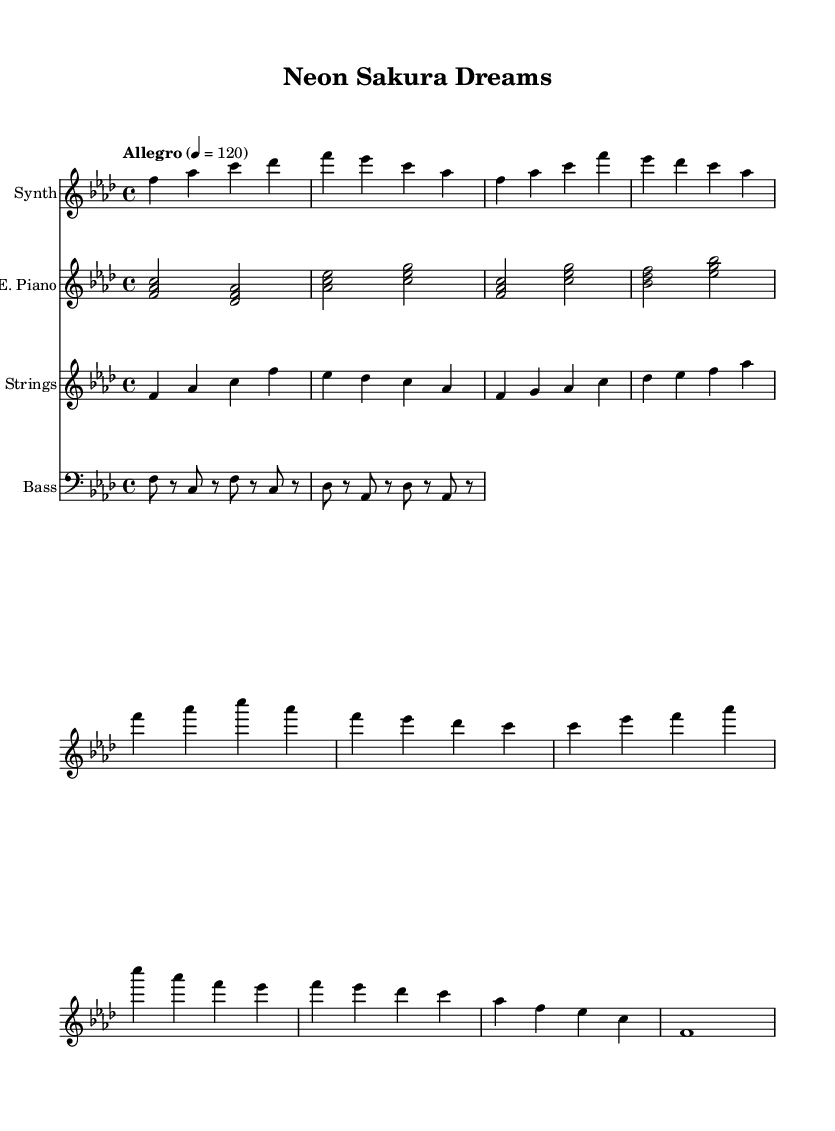What is the title of this piece? The title is indicated at the top of the sheet music in the header section. The title "Neon Sakura Dreams" is clearly labeled there.
Answer: Neon Sakura Dreams What is the key signature of this music? The key signature is found at the beginning of the staff, which indicates the sharps or flats used. Here, it shows four flats, indicating F minor.
Answer: F minor What is the time signature of this music? The time signature appears at the beginning of the score. It is written as 4/4, meaning there are four beats in each measure and the quarter note gets one beat.
Answer: 4/4 What is the tempo of this composition? The tempo marking is present at the beginning, which specifies the speed of the piece. It is indicated as "Allegro" with a metronome marking of 120 beats per minute.
Answer: Allegro What is the role of the electric piano in this composition? The electric piano plays chord progressions and complements the melody with harmonies throughout the piece. By examining the parts allocated, we can see it provides a harmonic foundation.
Answer: Chord progression How many sections are in the melody of the synth part? By analyzing the structure indicated in the synthesizer melody, we see segments labeled as Intro, Verse, Chorus, Bridge, and Outro; totaling five distinct sections.
Answer: Five Does the string part make use of any specific cultural elements? The string part includes runs that are inspired by Japanese pentatonic scales, which implies a cultural influence. The choice of notes and their arrangement supports this observation.
Answer: Japanese-inspired 